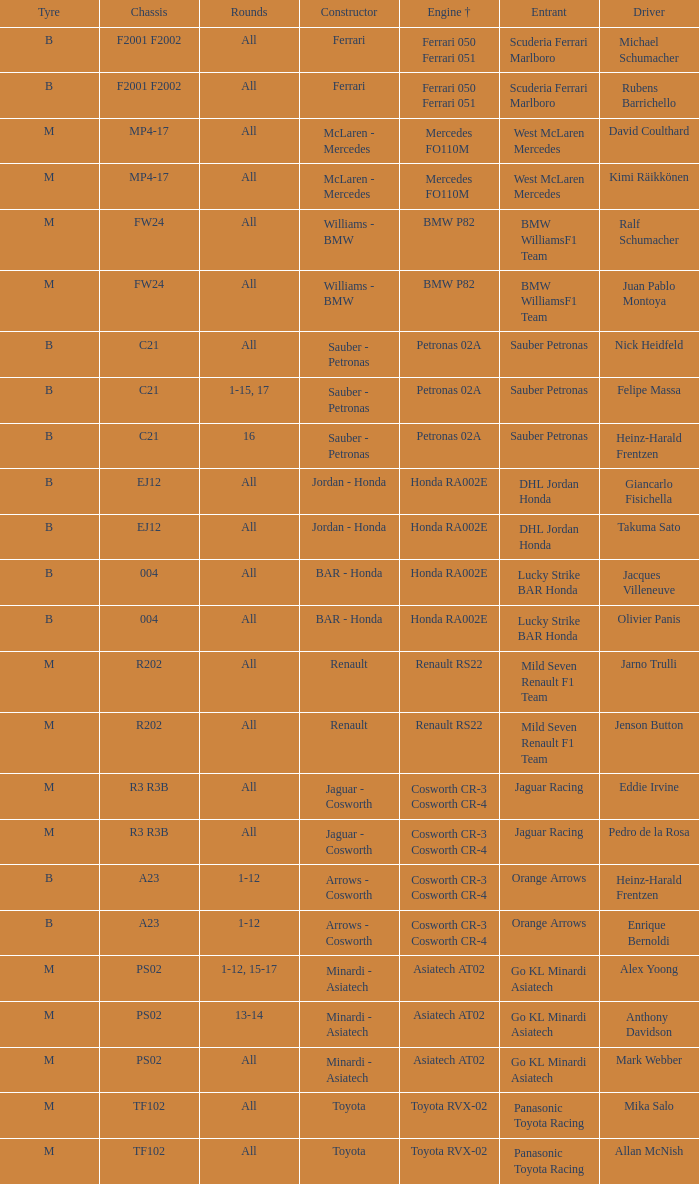What is the engine when the rounds ar all, the tyre is m and the driver is david coulthard? Mercedes FO110M. 